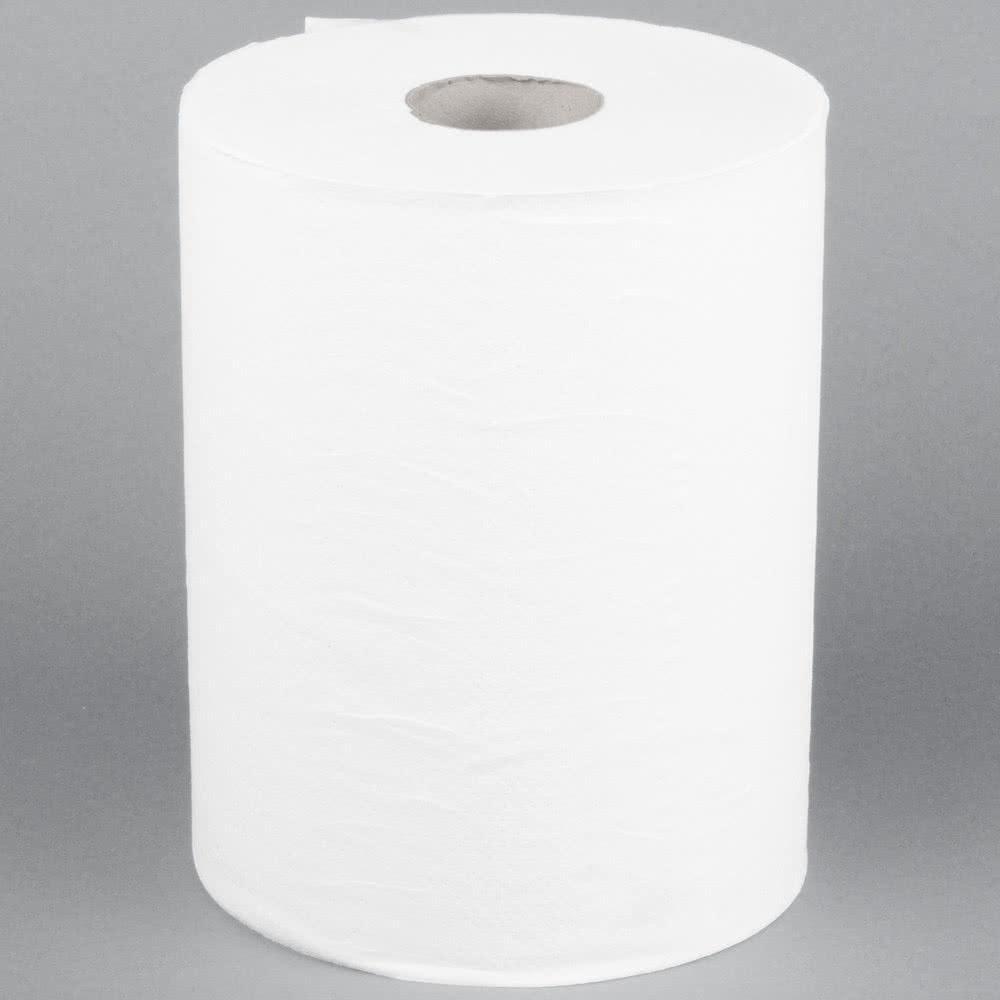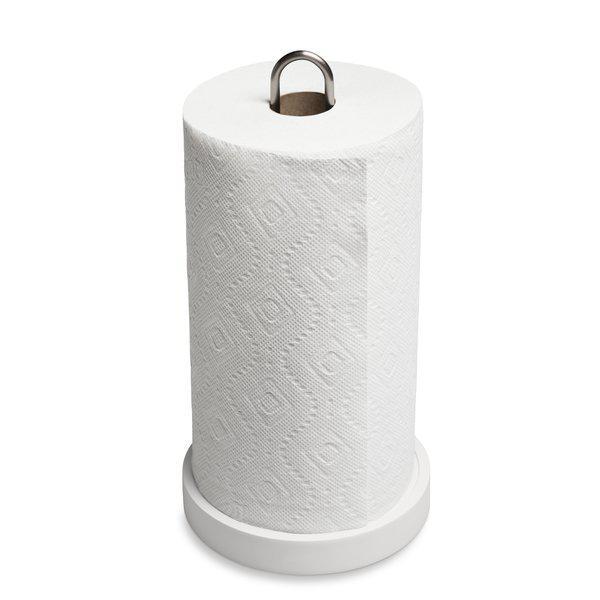The first image is the image on the left, the second image is the image on the right. Given the left and right images, does the statement "An image shows a roll of towels on an upright stand with a chrome part that extends out of the top." hold true? Answer yes or no. Yes. 